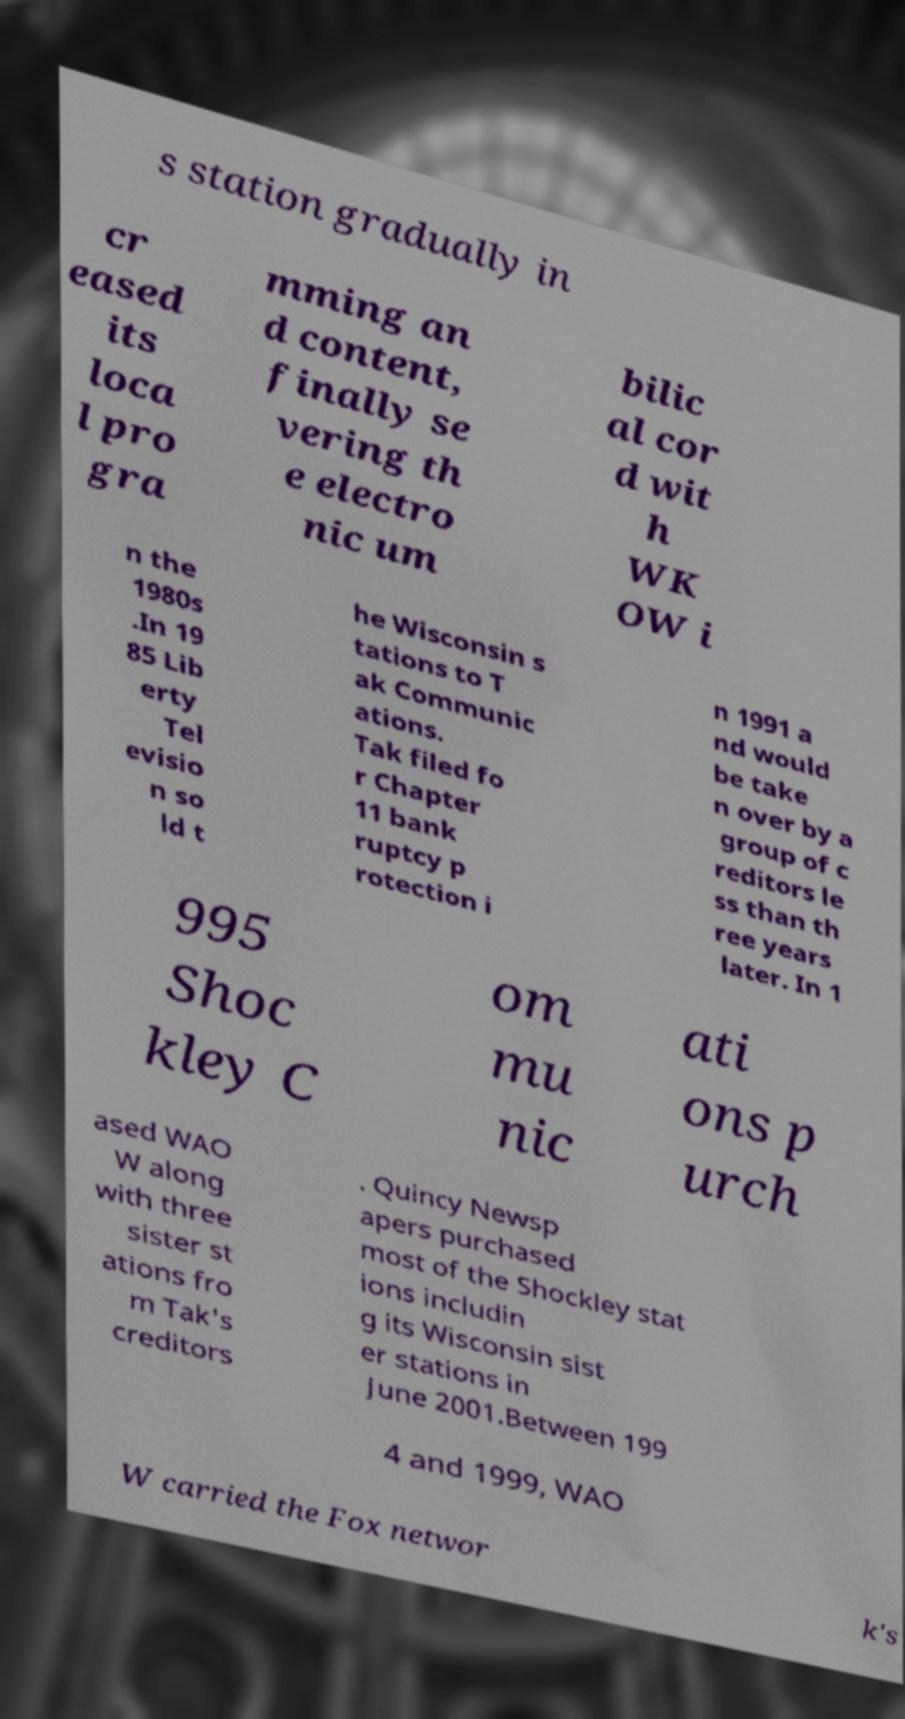What messages or text are displayed in this image? I need them in a readable, typed format. s station gradually in cr eased its loca l pro gra mming an d content, finally se vering th e electro nic um bilic al cor d wit h WK OW i n the 1980s .In 19 85 Lib erty Tel evisio n so ld t he Wisconsin s tations to T ak Communic ations. Tak filed fo r Chapter 11 bank ruptcy p rotection i n 1991 a nd would be take n over by a group of c reditors le ss than th ree years later. In 1 995 Shoc kley C om mu nic ati ons p urch ased WAO W along with three sister st ations fro m Tak's creditors . Quincy Newsp apers purchased most of the Shockley stat ions includin g its Wisconsin sist er stations in June 2001.Between 199 4 and 1999, WAO W carried the Fox networ k's 